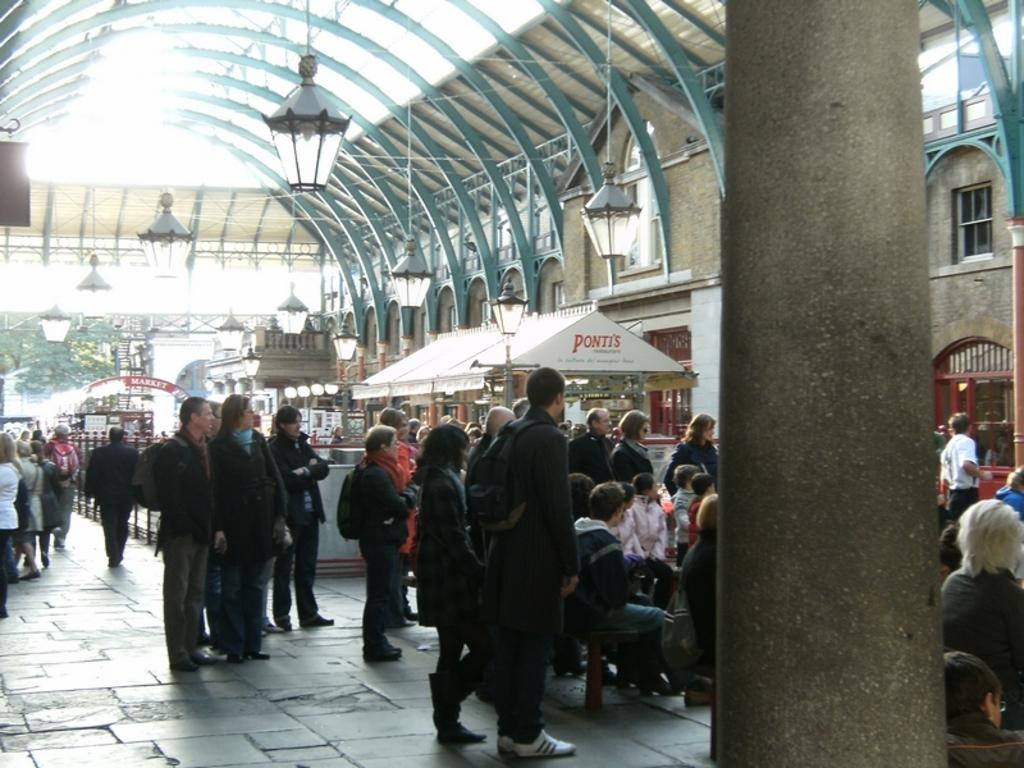<image>
Relay a brief, clear account of the picture shown. An event crowded with people includes a tent with "Ponti's" on it. 